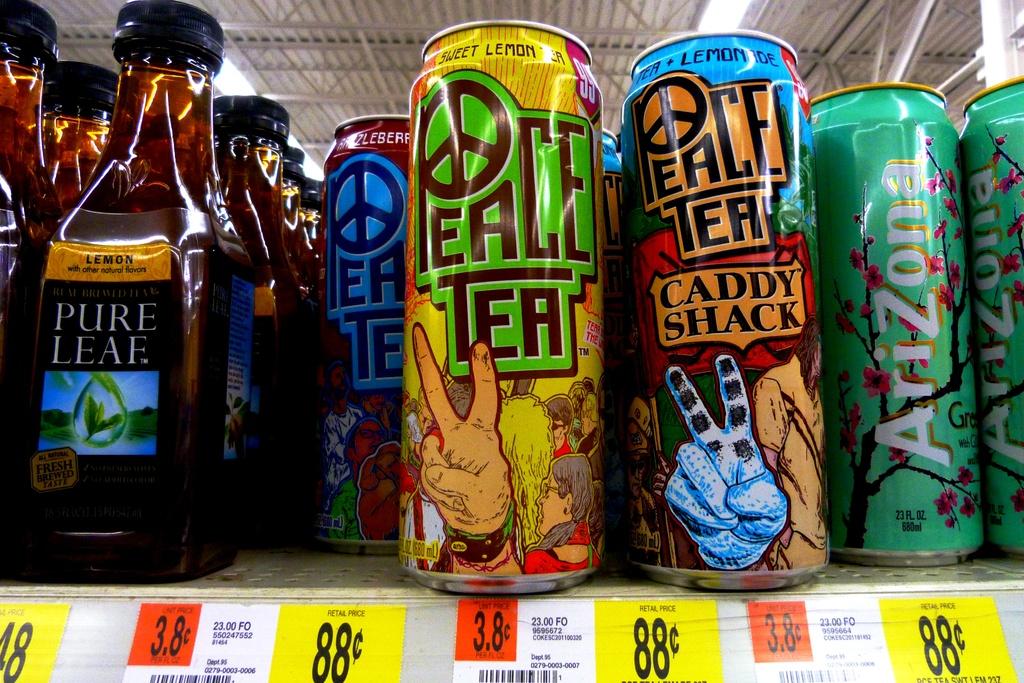What kind of tea is on the shelf?
Make the answer very short. Peace tea. How much is the cans of tea?
Ensure brevity in your answer.  88 cents. 